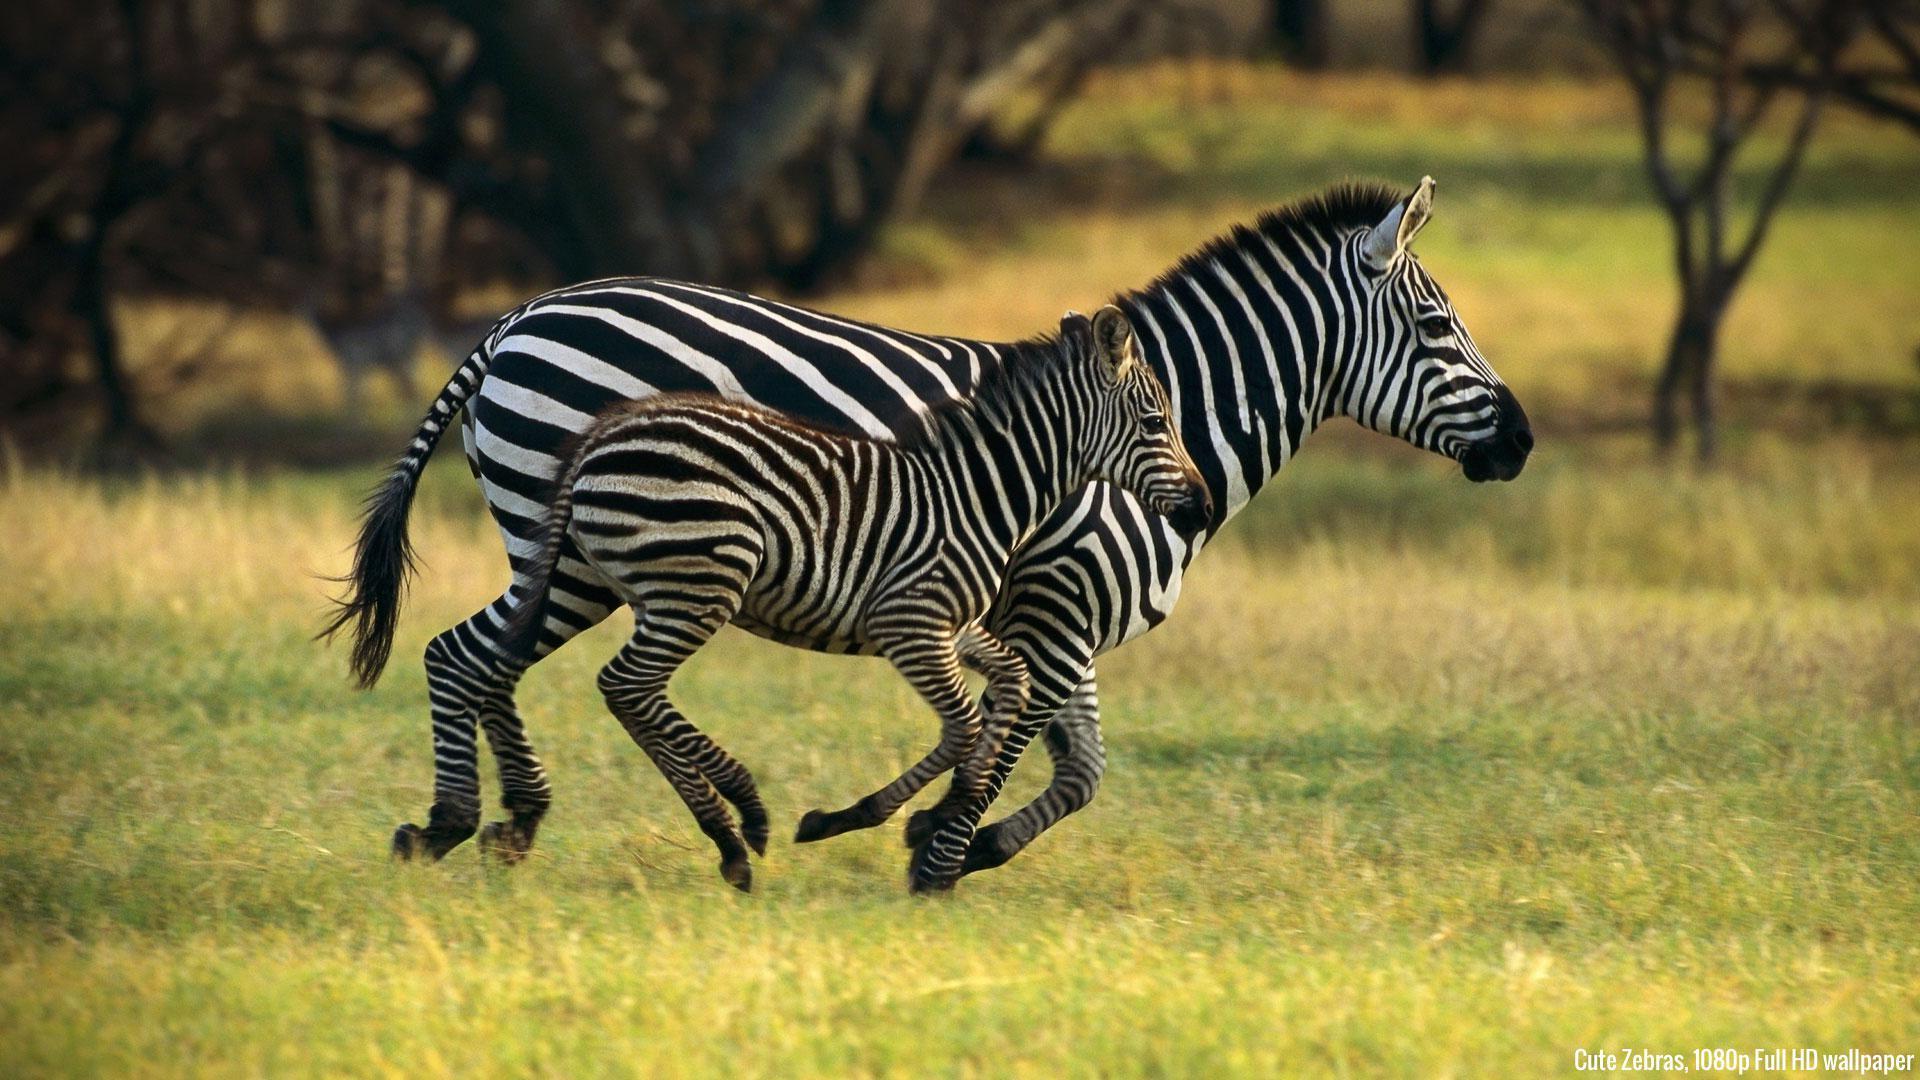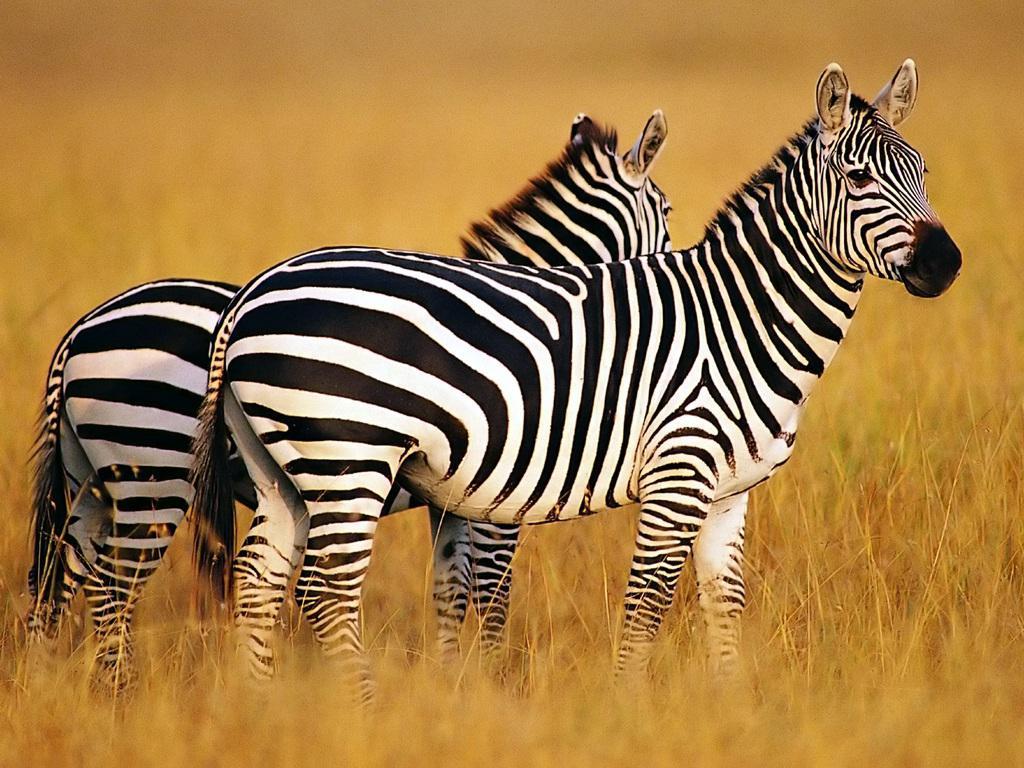The first image is the image on the left, the second image is the image on the right. Given the left and right images, does the statement "In one image, two similarly-sized zebras are standing side by side in the same direction." hold true? Answer yes or no. Yes. The first image is the image on the left, the second image is the image on the right. Examine the images to the left and right. Is the description "A young zebra can be seen with at least one adult zebra in one of the images." accurate? Answer yes or no. Yes. 